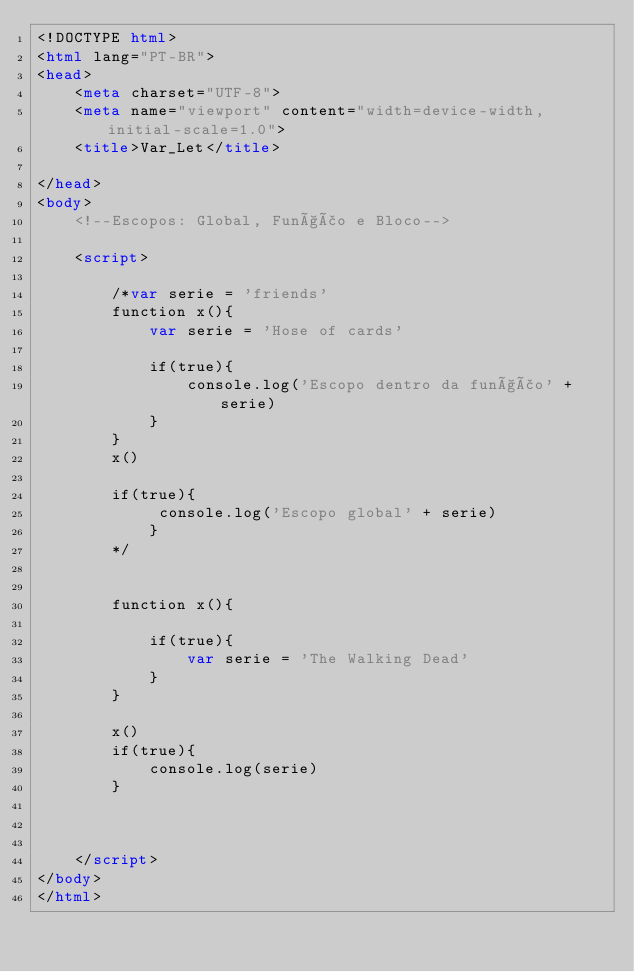Convert code to text. <code><loc_0><loc_0><loc_500><loc_500><_HTML_><!DOCTYPE html>
<html lang="PT-BR">
<head>
    <meta charset="UTF-8">
    <meta name="viewport" content="width=device-width, initial-scale=1.0">
    <title>Var_Let</title>

</head>
<body>
    <!--Escopos: Global, Função e Bloco-->

    <script>

        /*var serie = 'friends'
        function x(){
            var serie = 'Hose of cards'

            if(true){
                console.log('Escopo dentro da função' + serie)
            }
        }
        x()

        if(true){
             console.log('Escopo global' + serie)   
            }
        */

        
        function x(){
            
            if(true){
                var serie = 'The Walking Dead'
            }
        }
        
        x()
        if(true){
            console.log(serie)   
        }
          
            
        
    </script>
</body>
</html></code> 